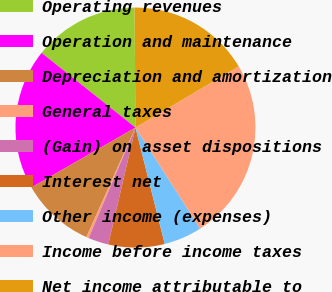<chart> <loc_0><loc_0><loc_500><loc_500><pie_chart><fcel>Operating revenues<fcel>Operation and maintenance<fcel>Depreciation and amortization<fcel>General taxes<fcel>(Gain) on asset dispositions<fcel>Interest net<fcel>Other income (expenses)<fcel>Income before income taxes<fcel>Net income attributable to<nl><fcel>14.18%<fcel>19.01%<fcel>9.98%<fcel>0.33%<fcel>2.74%<fcel>7.56%<fcel>5.15%<fcel>24.45%<fcel>16.6%<nl></chart> 